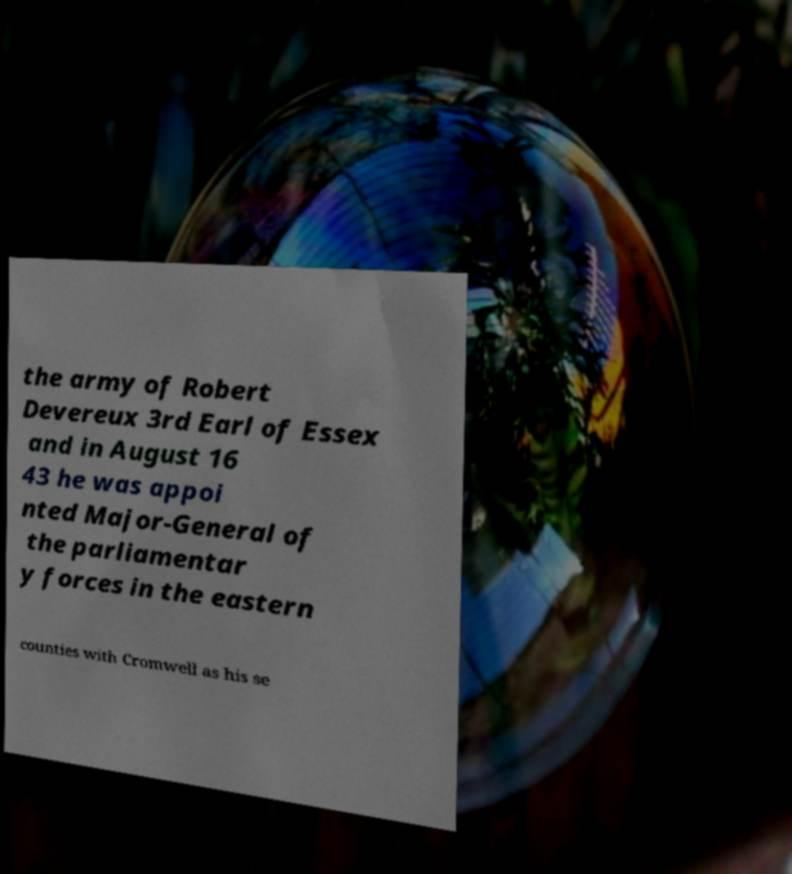Can you accurately transcribe the text from the provided image for me? the army of Robert Devereux 3rd Earl of Essex and in August 16 43 he was appoi nted Major-General of the parliamentar y forces in the eastern counties with Cromwell as his se 